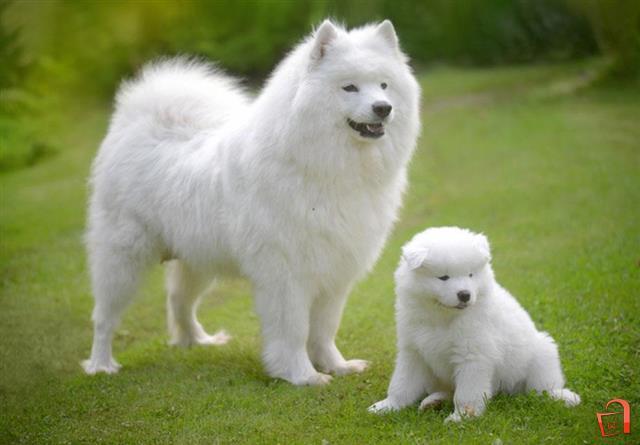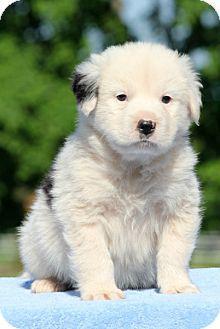The first image is the image on the left, the second image is the image on the right. Given the left and right images, does the statement "there ia a puppy sitting on something that isn't grass" hold true? Answer yes or no. Yes. The first image is the image on the left, the second image is the image on the right. Examine the images to the left and right. Is the description "There are exactly three dogs." accurate? Answer yes or no. Yes. 